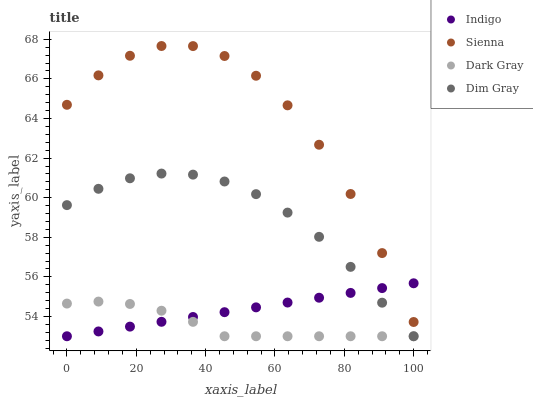Does Dark Gray have the minimum area under the curve?
Answer yes or no. Yes. Does Sienna have the maximum area under the curve?
Answer yes or no. Yes. Does Dim Gray have the minimum area under the curve?
Answer yes or no. No. Does Dim Gray have the maximum area under the curve?
Answer yes or no. No. Is Indigo the smoothest?
Answer yes or no. Yes. Is Sienna the roughest?
Answer yes or no. Yes. Is Dark Gray the smoothest?
Answer yes or no. No. Is Dark Gray the roughest?
Answer yes or no. No. Does Dark Gray have the lowest value?
Answer yes or no. Yes. Does Sienna have the highest value?
Answer yes or no. Yes. Does Dim Gray have the highest value?
Answer yes or no. No. Is Dim Gray less than Sienna?
Answer yes or no. Yes. Is Sienna greater than Dim Gray?
Answer yes or no. Yes. Does Dark Gray intersect Indigo?
Answer yes or no. Yes. Is Dark Gray less than Indigo?
Answer yes or no. No. Is Dark Gray greater than Indigo?
Answer yes or no. No. Does Dim Gray intersect Sienna?
Answer yes or no. No. 